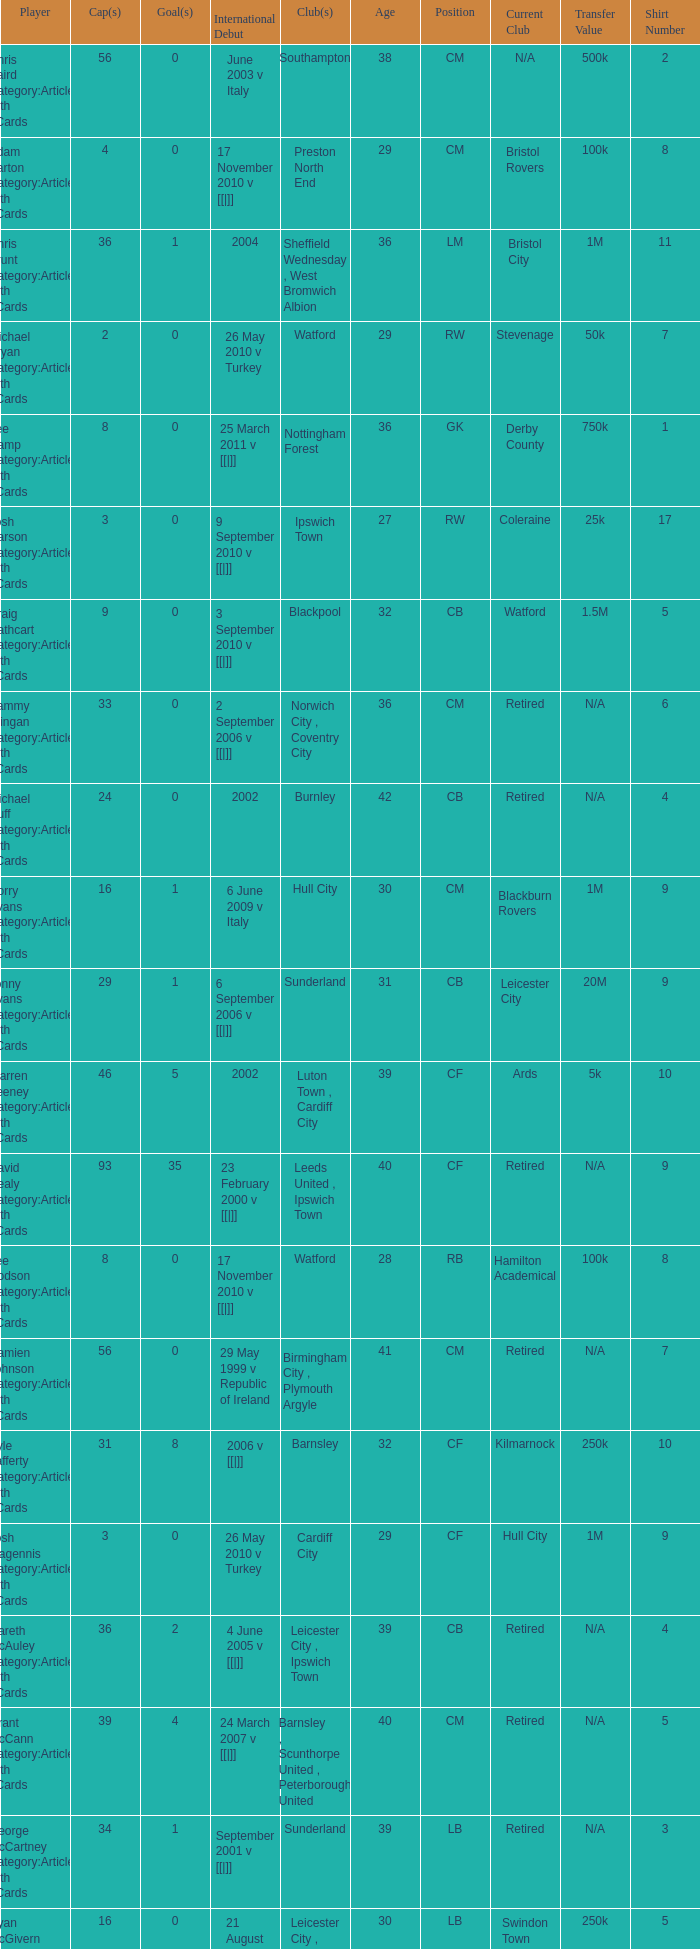How many caps figures for the Doncaster Rovers? 1.0. 